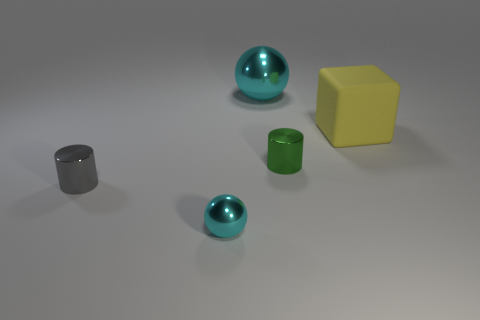Add 1 matte blocks. How many objects exist? 6 Subtract 2 cylinders. How many cylinders are left? 0 Subtract all cylinders. How many objects are left? 3 Subtract all small green cylinders. Subtract all tiny gray cylinders. How many objects are left? 3 Add 4 large cyan things. How many large cyan things are left? 5 Add 2 small blocks. How many small blocks exist? 2 Subtract 0 purple cylinders. How many objects are left? 5 Subtract all red cubes. Subtract all yellow cylinders. How many cubes are left? 1 